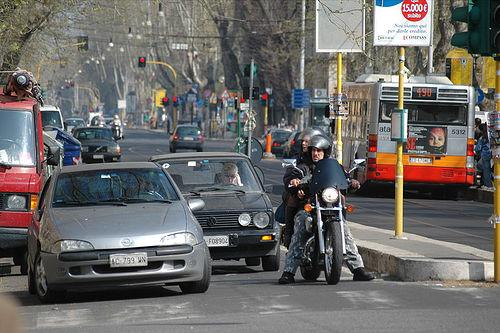Why are all the vehicles on the left not moving? traffic 